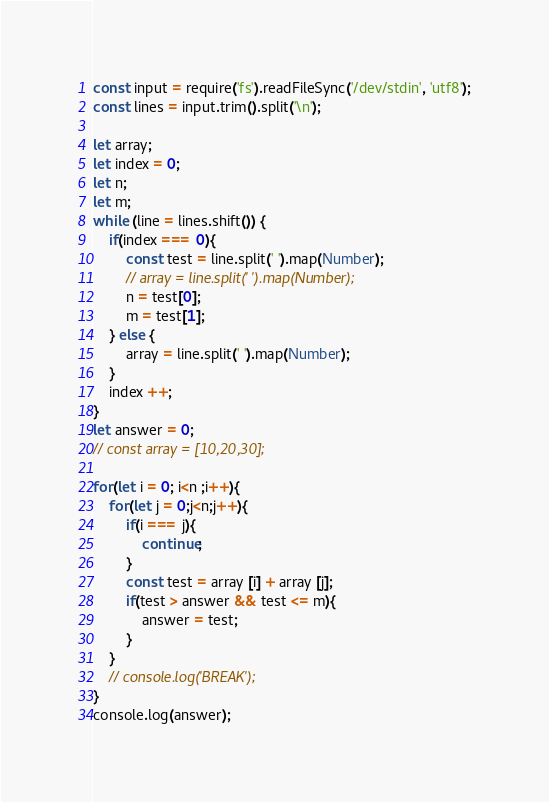Convert code to text. <code><loc_0><loc_0><loc_500><loc_500><_JavaScript_>const input = require('fs').readFileSync('/dev/stdin', 'utf8');
const lines = input.trim().split('\n');

let array;
let index = 0;
let n;
let m;
while (line = lines.shift()) {
    if(index === 0){
        const test = line.split(' ').map(Number);
        // array = line.split(' ').map(Number);
        n = test[0];
        m = test[1];
    } else {
        array = line.split(' ').map(Number);
    }
    index ++;
}
let answer = 0;
// const array = [10,20,30];

for(let i = 0; i<n ;i++){
    for(let j = 0;j<n;j++){
        if(i === j){
            continue;
        }
        const test = array [i] + array [j];
        if(test > answer && test <= m){
            answer = test;
        }
    }
    // console.log('BREAK');
}
console.log(answer);
</code> 